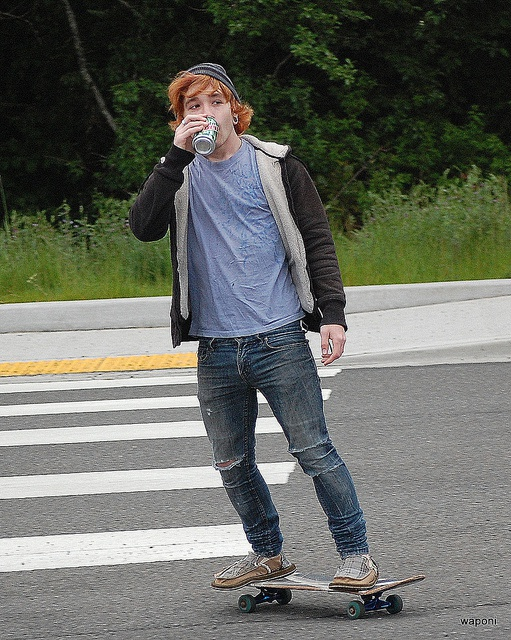Describe the objects in this image and their specific colors. I can see people in black, gray, and darkgray tones and skateboard in black, darkgray, gray, and lightgray tones in this image. 